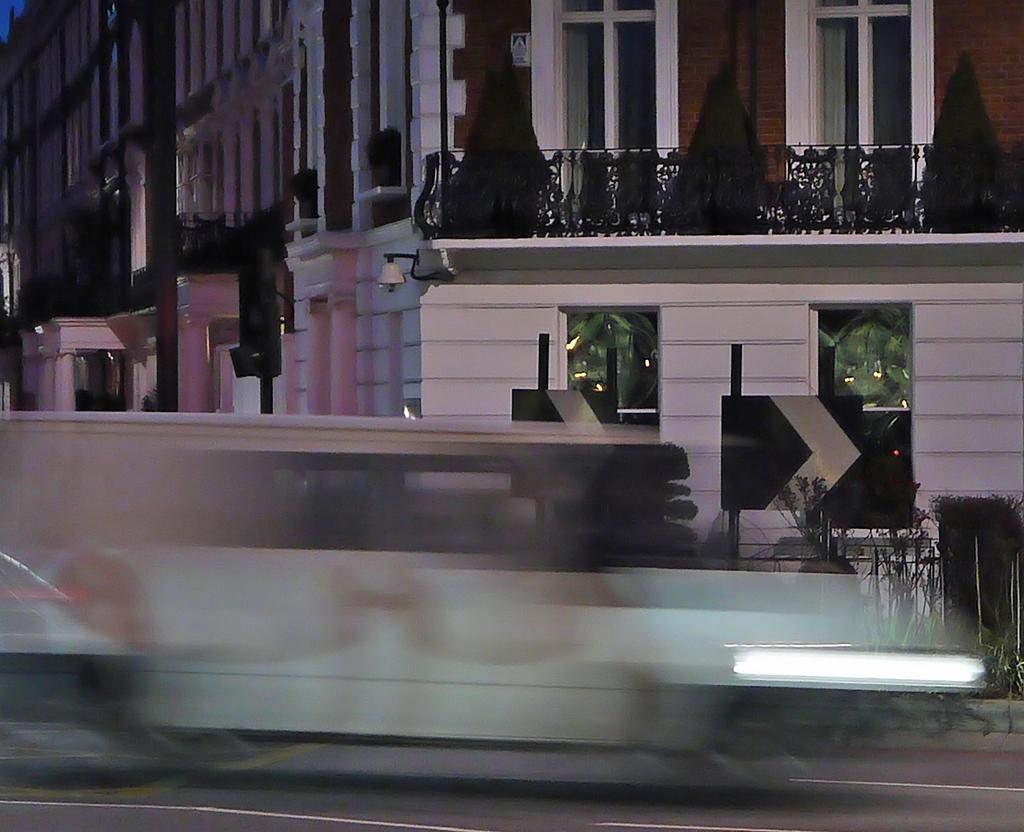Describe this image in one or two sentences. The front of the image is blurred, behind the blurred part there are sign boards and plants on the pavement. In the background of the image there are traffic lights and buildings. 